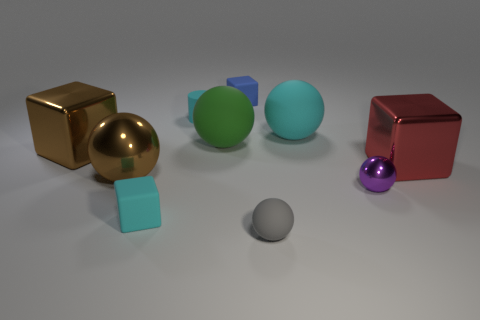Subtract all big red blocks. How many blocks are left? 3 Subtract all blue blocks. How many blocks are left? 3 Subtract all brown blocks. Subtract all blue balls. How many blocks are left? 3 Add 3 spheres. How many spheres are left? 8 Add 6 big matte things. How many big matte things exist? 8 Subtract 0 yellow cylinders. How many objects are left? 10 Subtract all cylinders. How many objects are left? 9 Subtract all purple metallic things. Subtract all small balls. How many objects are left? 7 